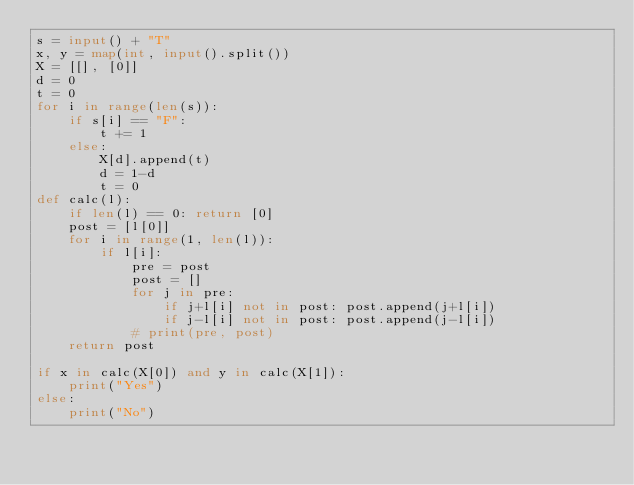<code> <loc_0><loc_0><loc_500><loc_500><_Python_>s = input() + "T"
x, y = map(int, input().split())
X = [[], [0]]
d = 0
t = 0
for i in range(len(s)):
    if s[i] == "F":
        t += 1
    else:
        X[d].append(t)
        d = 1-d
        t = 0
def calc(l):
    if len(l) == 0: return [0] 
    post = [l[0]]
    for i in range(1, len(l)):
        if l[i]:
            pre = post
            post = []
            for j in pre:
                if j+l[i] not in post: post.append(j+l[i])
                if j-l[i] not in post: post.append(j-l[i])
            # print(pre, post)
    return post

if x in calc(X[0]) and y in calc(X[1]):
    print("Yes")
else:
    print("No")</code> 